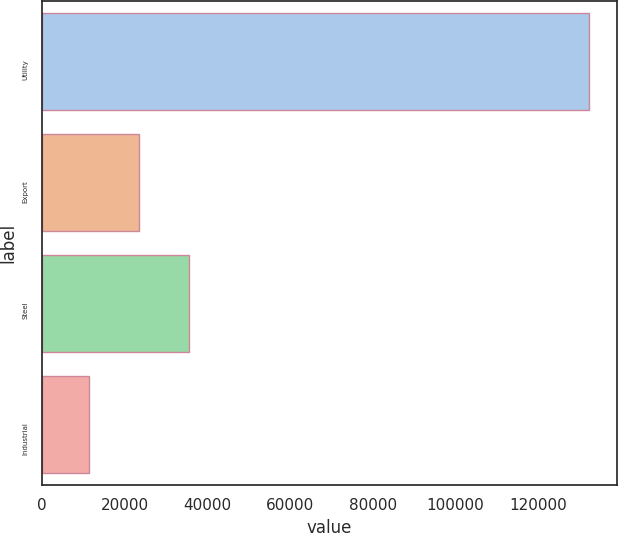Convert chart. <chart><loc_0><loc_0><loc_500><loc_500><bar_chart><fcel>Utility<fcel>Export<fcel>Steel<fcel>Industrial<nl><fcel>132325<fcel>23471.8<fcel>35566.6<fcel>11377<nl></chart> 